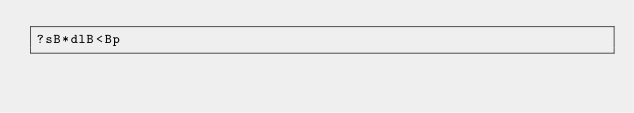Convert code to text. <code><loc_0><loc_0><loc_500><loc_500><_dc_>?sB*dlB<Bp</code> 